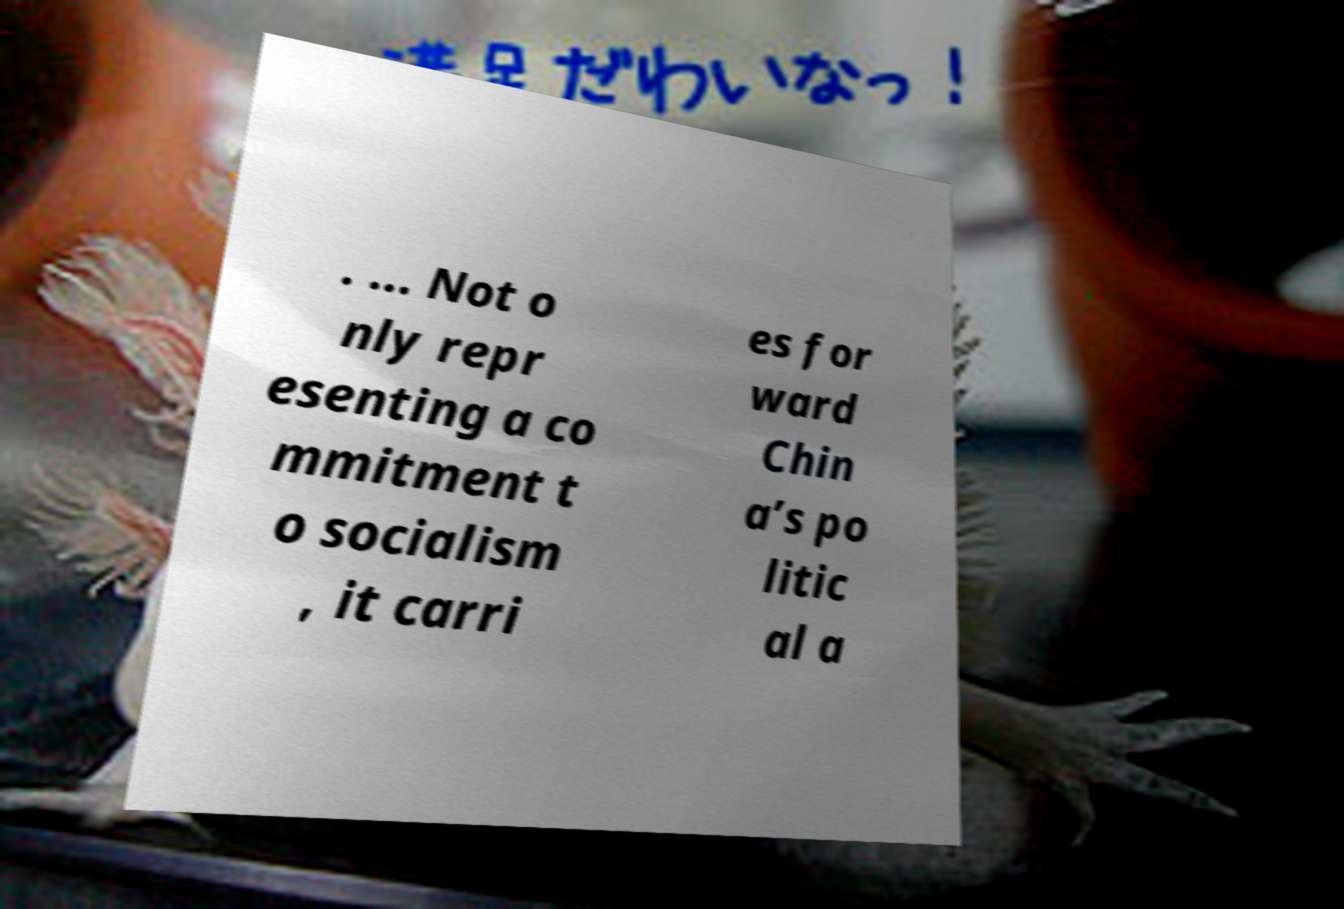Could you extract and type out the text from this image? . ... Not o nly repr esenting a co mmitment t o socialism , it carri es for ward Chin a’s po litic al a 